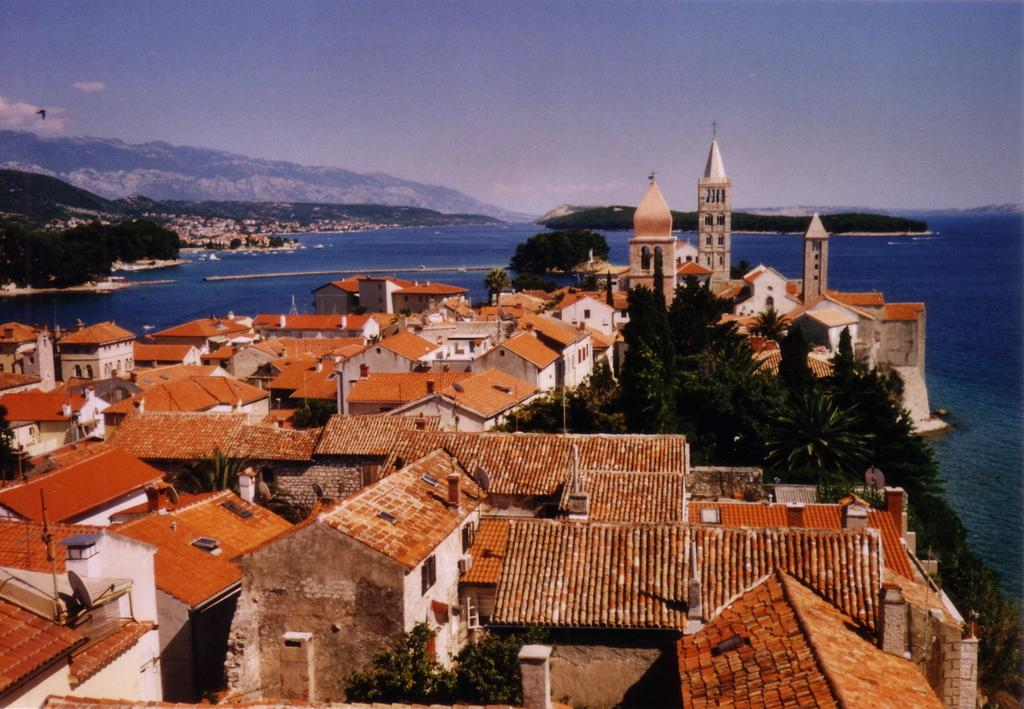What type of buildings can be seen in the image? There are houses and churches in the image. Where are the houses and churches located? The houses and churches are beside the sea. What type of vegetation is on the right side of the image? There are trees on the right side of the image. What can be seen in the background of the image? There is a huge mountain in the background of the image. What advice does the mountain give to the houses and churches in the image? The mountain does not give any advice to the houses and churches in the image, as it is an inanimate object and cannot communicate. 